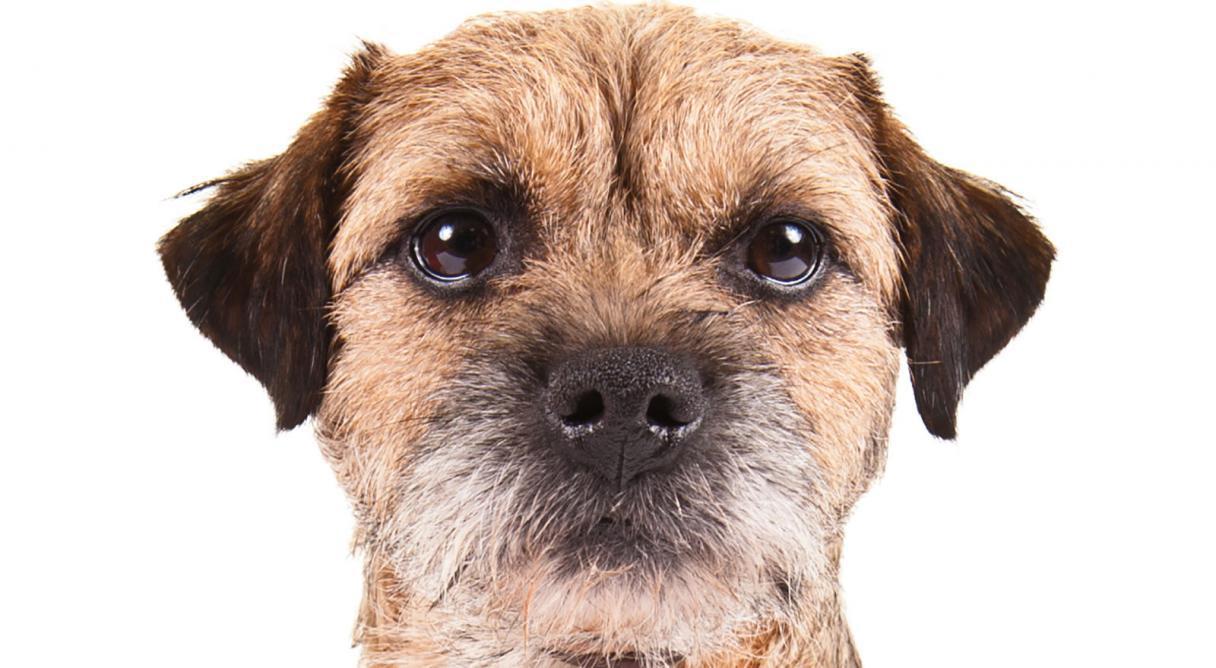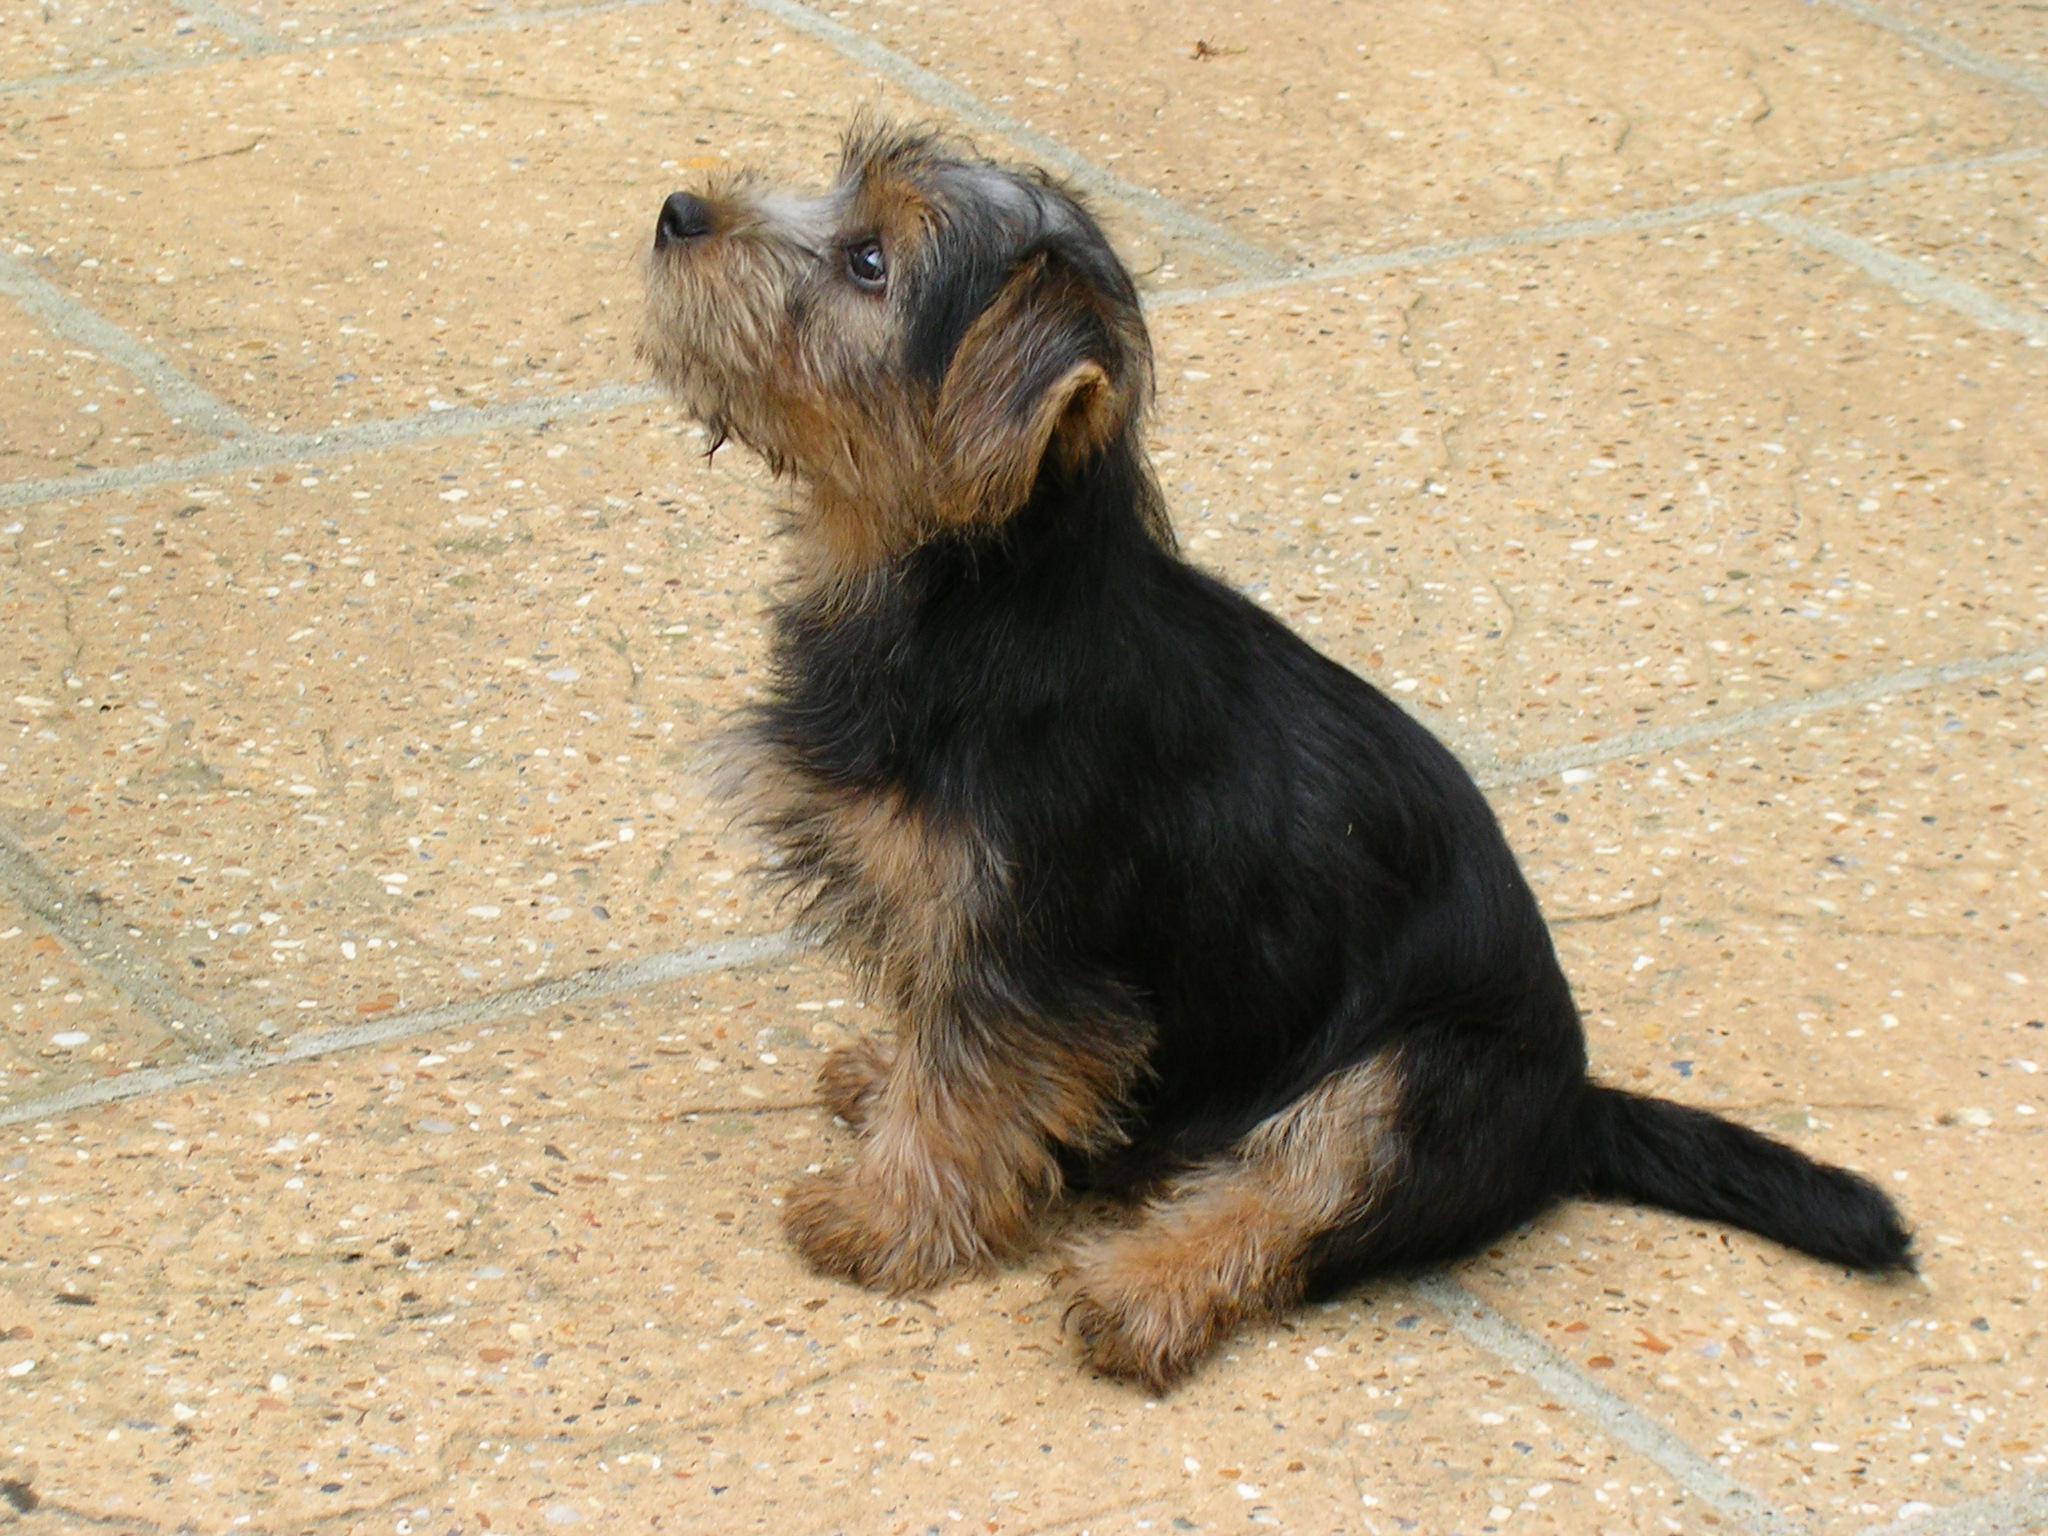The first image is the image on the left, the second image is the image on the right. For the images displayed, is the sentence "One photo shows the full body of an adult dog against a plain white background." factually correct? Answer yes or no. No. The first image is the image on the left, the second image is the image on the right. Analyze the images presented: Is the assertion "One dog has a collar or leash." valid? Answer yes or no. No. 